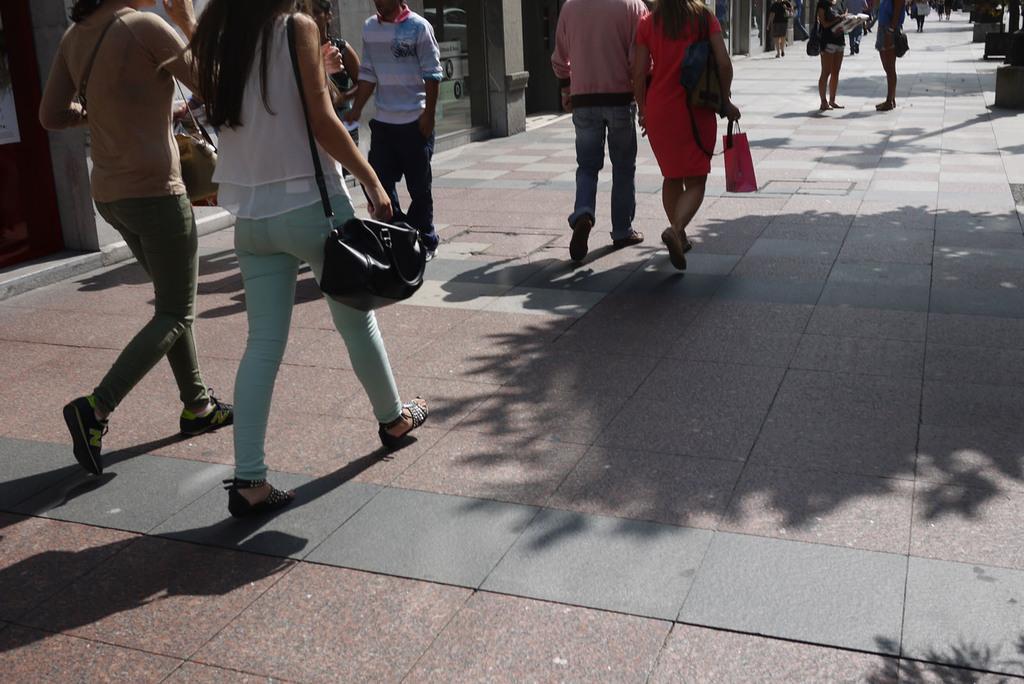How would you summarize this image in a sentence or two? There are some people walking on this path. There are men and women on this road. In the background there are some buildings here. 